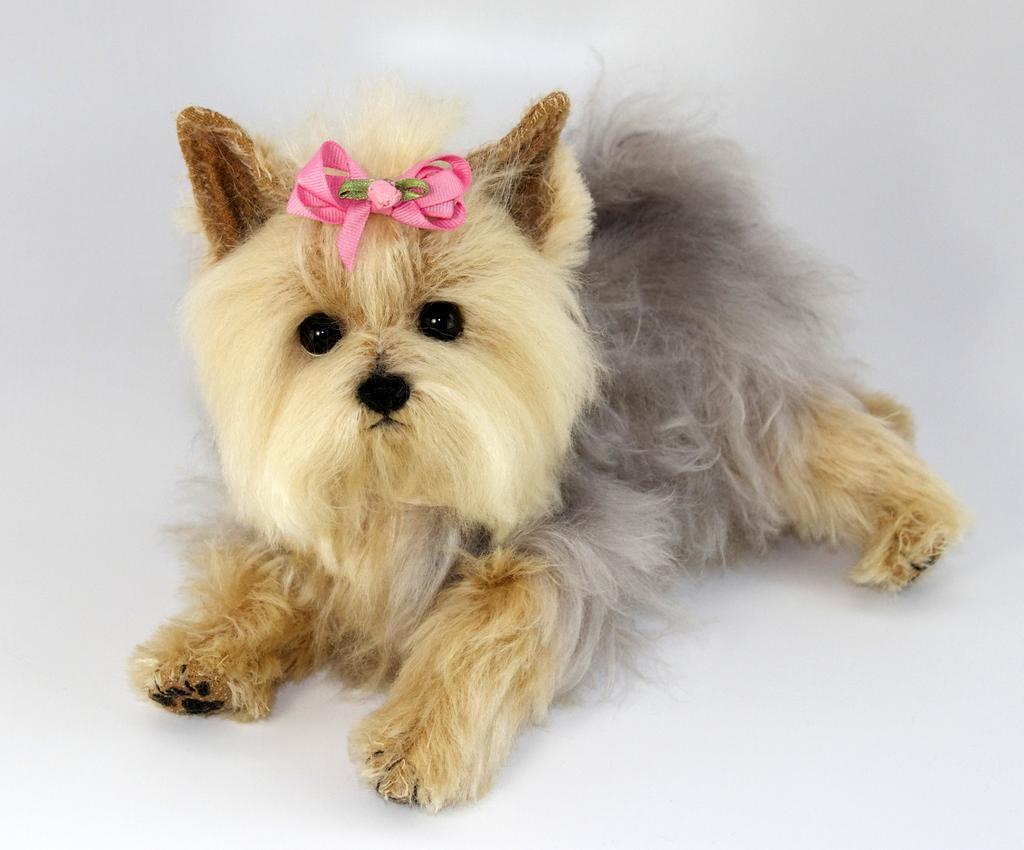How would you summarize this image in a sentence or two? In this picture we can see a dog. We can see an object on the head of a dog. Remaining portion of the picture is in white color. 